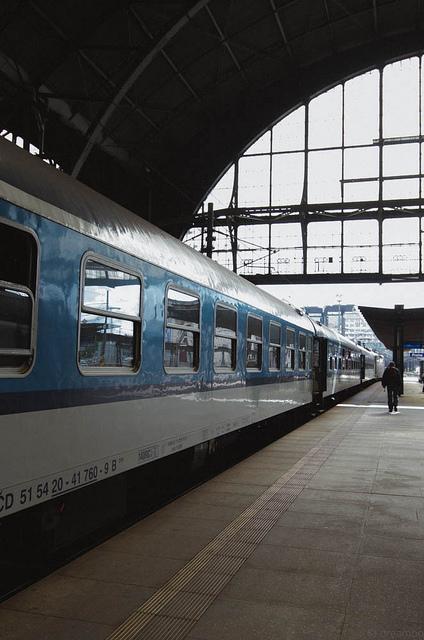Is this a modern train?
Be succinct. Yes. Is the train in the station or outside of it?
Concise answer only. Inside. Is it night time?
Give a very brief answer. No. Is the man walking to the camera?
Short answer required. No. What color are the trains?
Keep it brief. Blue and silver. 